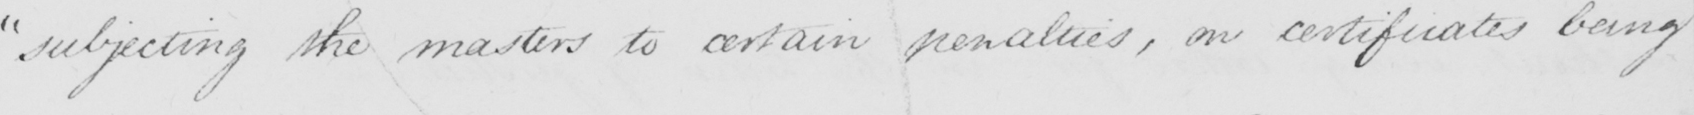Transcribe the text shown in this historical manuscript line. " subjecting the masters to certain penalties , on certificates being 